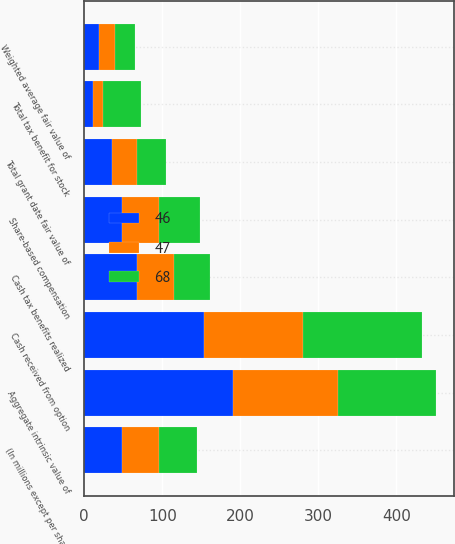Convert chart to OTSL. <chart><loc_0><loc_0><loc_500><loc_500><stacked_bar_chart><ecel><fcel>(In millions except per share<fcel>Weighted average fair value of<fcel>Total grant date fair value of<fcel>Aggregate intrinsic value of<fcel>Share-based compensation<fcel>Total tax benefit for stock<fcel>Cash received from option<fcel>Cash tax benefits realized<nl><fcel>68<fcel>48<fcel>25.54<fcel>37<fcel>126<fcel>52<fcel>49<fcel>153<fcel>46<nl><fcel>47<fcel>48<fcel>20.35<fcel>32<fcel>134<fcel>48<fcel>13<fcel>126<fcel>47<nl><fcel>46<fcel>48<fcel>19.39<fcel>36<fcel>191<fcel>48<fcel>11<fcel>154<fcel>68<nl></chart> 